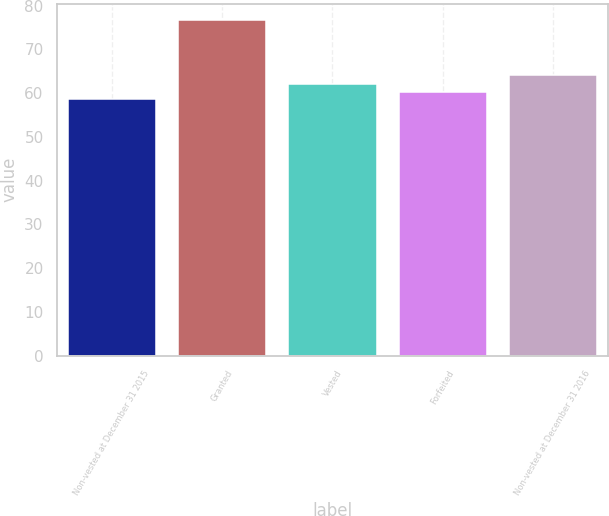Convert chart. <chart><loc_0><loc_0><loc_500><loc_500><bar_chart><fcel>Non-vested at December 31 2015<fcel>Granted<fcel>Vested<fcel>Forfeited<fcel>Non-vested at December 31 2016<nl><fcel>58.56<fcel>76.62<fcel>62.18<fcel>60.37<fcel>64.04<nl></chart> 